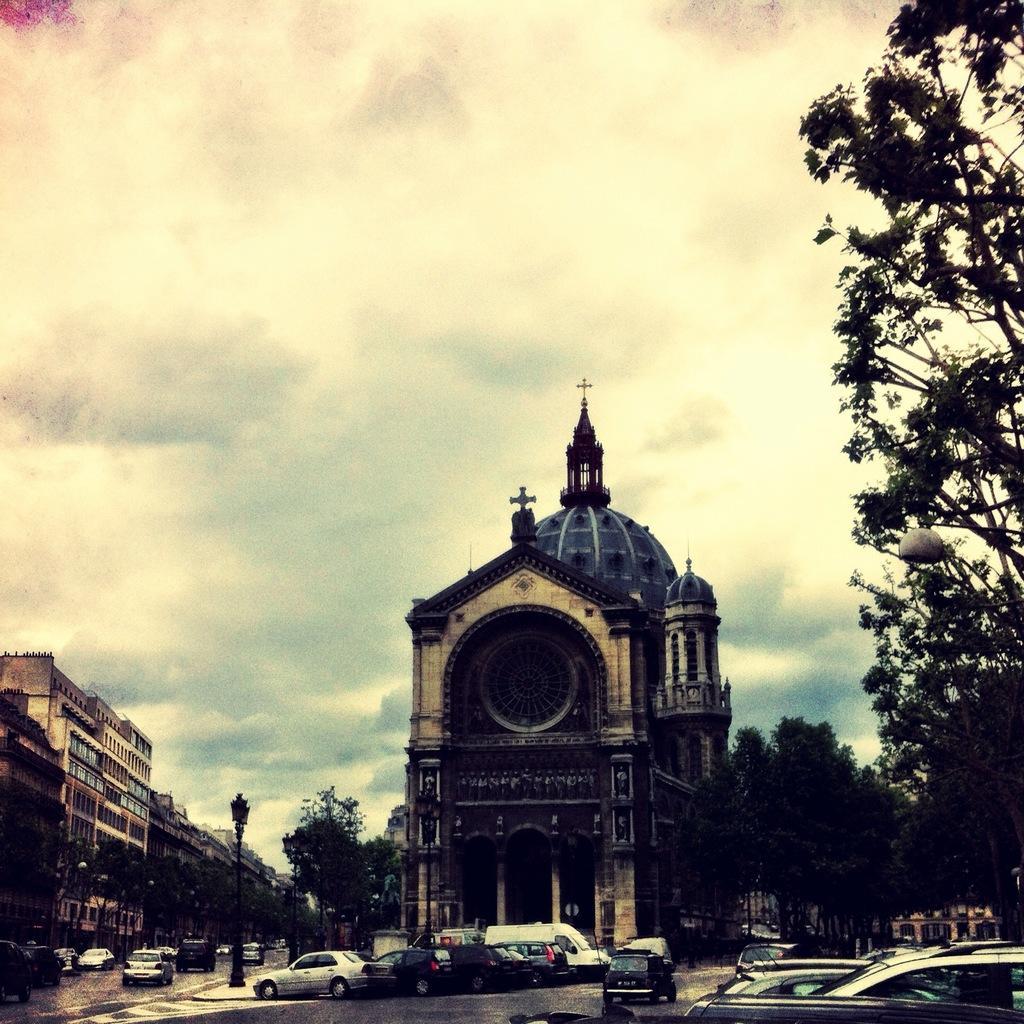Please provide a concise description of this image. In this picture we can see cars on the road, buildings, trees, pole and in the background we can see the sky with clouds. 